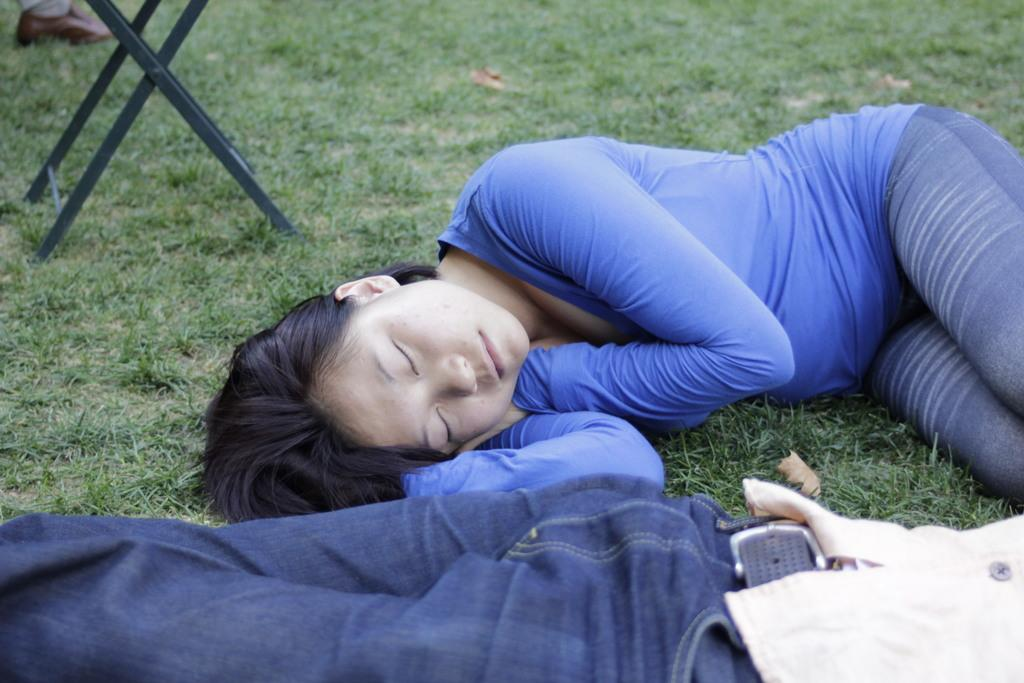How many people are in the image? There are two people in the image. What are the two people doing in the image? The two people are lying on the grass. Can you describe any other objects or structures in the image? Yes, there is a table in the image. Did the earthquake cause the oven to fall over in the image? There is no earthquake or oven present in the image. 